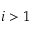Convert formula to latex. <formula><loc_0><loc_0><loc_500><loc_500>i > 1</formula> 